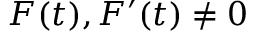Convert formula to latex. <formula><loc_0><loc_0><loc_500><loc_500>F ( t ) , F ^ { \prime } ( t ) \neq 0</formula> 